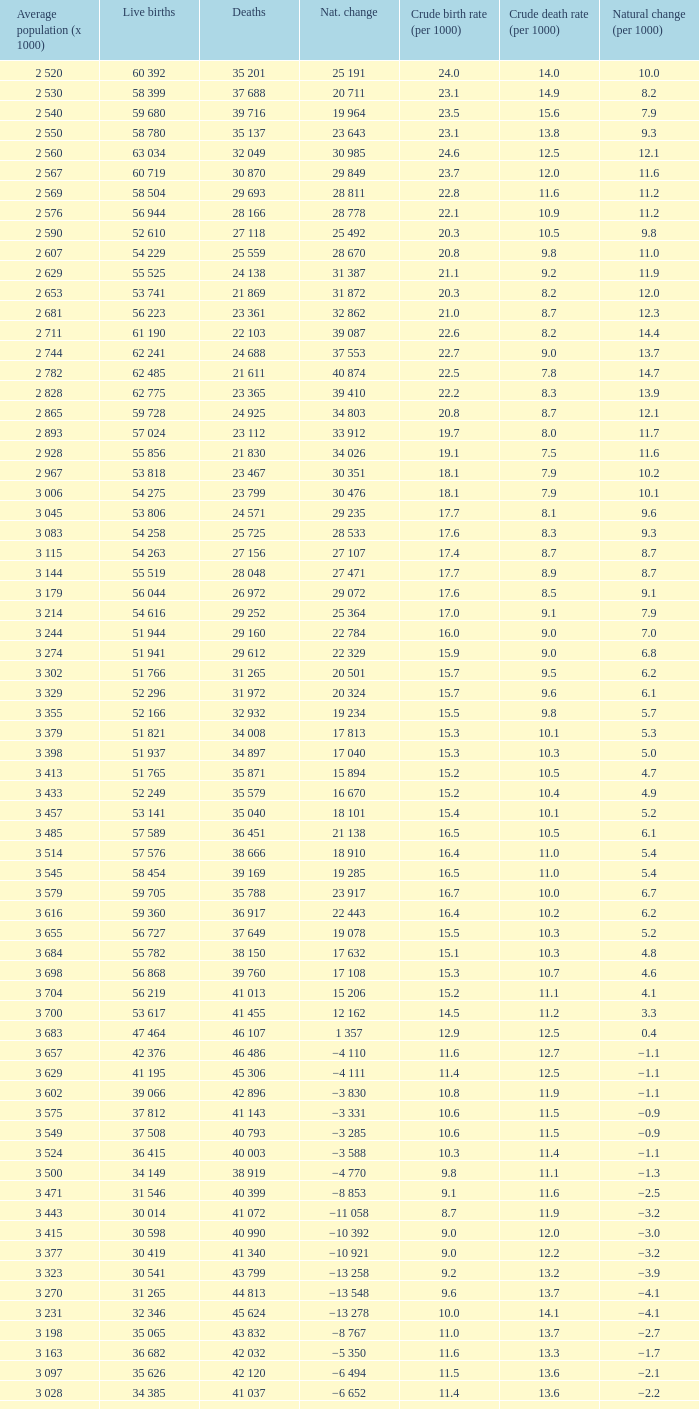Which Natural change has a Crude death rate (per 1000) larger than 9, and Deaths of 40 399? −8 853. 